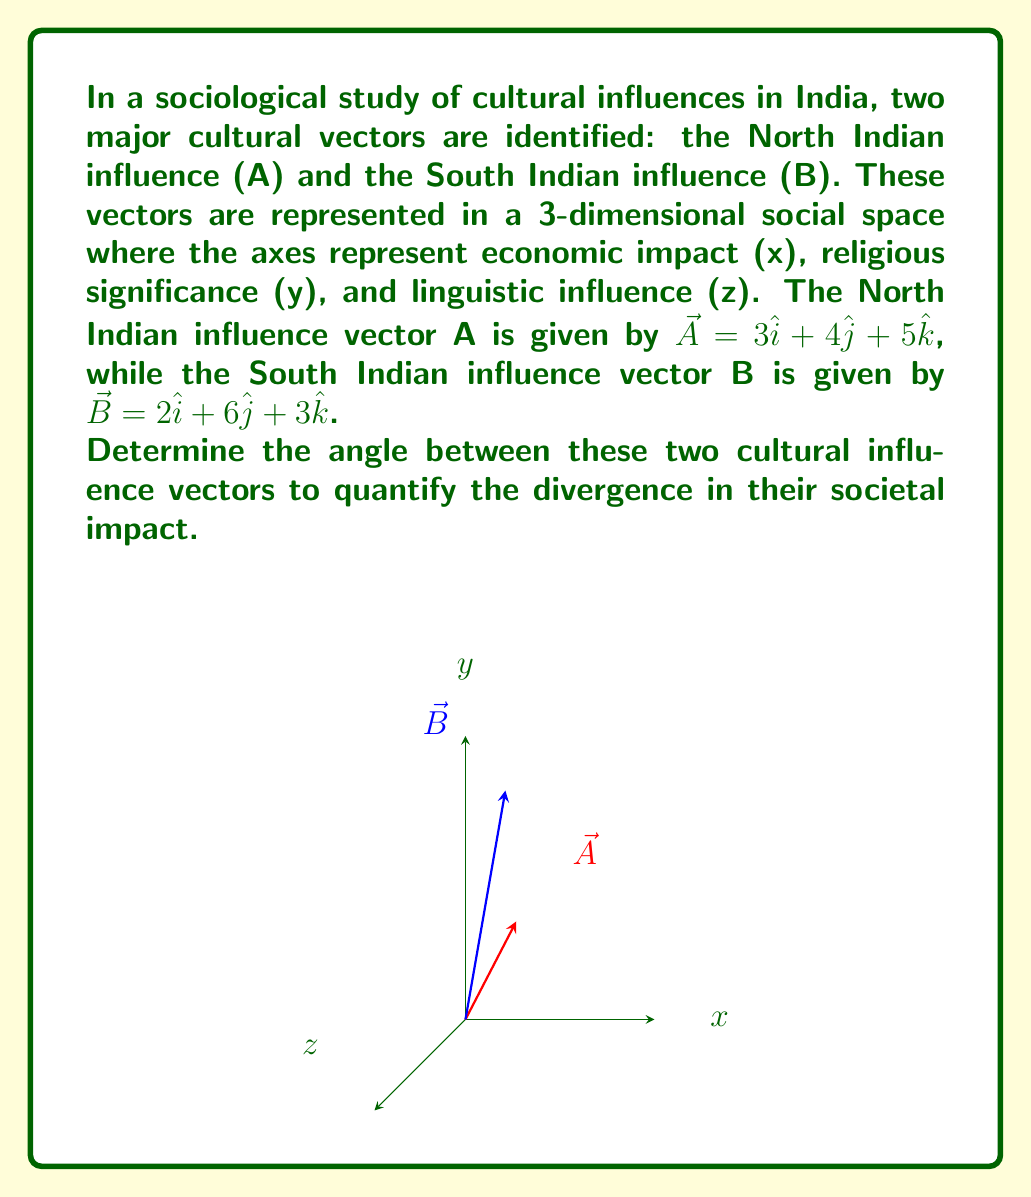Show me your answer to this math problem. To find the angle between two vectors, we can use the dot product formula:

$$\cos \theta = \frac{\vec{A} \cdot \vec{B}}{|\vec{A}||\vec{B}|}$$

Let's solve this step-by-step:

1) First, calculate the dot product $\vec{A} \cdot \vec{B}$:
   $$\vec{A} \cdot \vec{B} = (3)(2) + (4)(6) + (5)(3) = 6 + 24 + 15 = 45$$

2) Next, calculate the magnitudes of $\vec{A}$ and $\vec{B}$:
   $$|\vec{A}| = \sqrt{3^2 + 4^2 + 5^2} = \sqrt{9 + 16 + 25} = \sqrt{50}$$
   $$|\vec{B}| = \sqrt{2^2 + 6^2 + 3^2} = \sqrt{4 + 36 + 9} = \sqrt{49} = 7$$

3) Now, substitute these values into the cosine formula:
   $$\cos \theta = \frac{45}{\sqrt{50} \cdot 7}$$

4) Simplify:
   $$\cos \theta = \frac{45}{7\sqrt{50}} = \frac{45}{7\sqrt{25 \cdot 2}} = \frac{45}{35\sqrt{2}} = \frac{9}{7\sqrt{2}}$$

5) To find $\theta$, we need to take the inverse cosine (arccos) of both sides:
   $$\theta = \arccos(\frac{9}{7\sqrt{2}})$$

6) Using a calculator or computer, we can evaluate this:
   $$\theta \approx 0.5536 \text{ radians}$$

7) Convert to degrees:
   $$\theta \approx 0.5536 \cdot \frac{180}{\pi} \approx 31.72°$$

This angle represents the divergence between the North and South Indian cultural influences in the given social space.
Answer: $\theta \approx 31.72°$ 